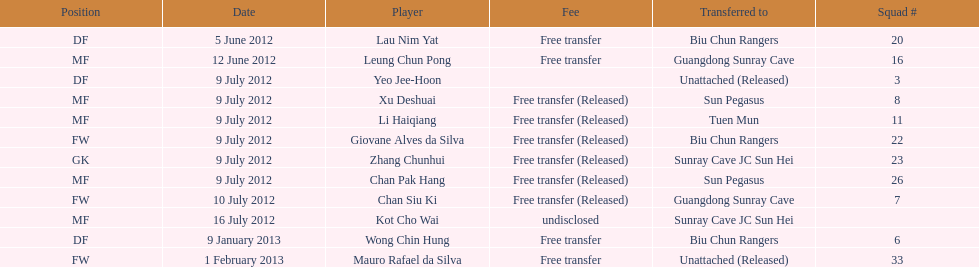How many total players were transferred to sun pegasus? 2. 